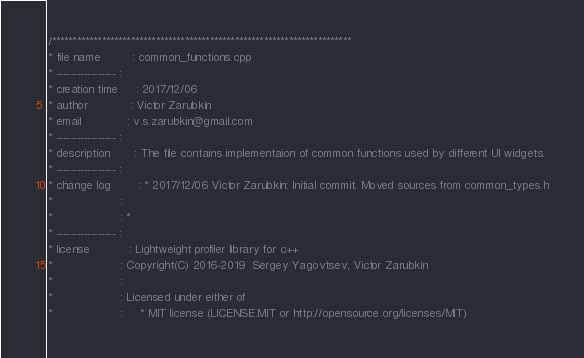Convert code to text. <code><loc_0><loc_0><loc_500><loc_500><_C++_>/************************************************************************
* file name         : common_functions.cpp
* ----------------- :
* creation time     : 2017/12/06
* author            : Victor Zarubkin
* email             : v.s.zarubkin@gmail.com
* ----------------- :
* description       : The file contains implementaion of common functions used by different UI widgets.
* ----------------- :
* change log        : * 2017/12/06 Victor Zarubkin: Initial commit. Moved sources from common_types.h
*                   :
*                   : *
* ----------------- :
* license           : Lightweight profiler library for c++
*                   : Copyright(C) 2016-2019  Sergey Yagovtsev, Victor Zarubkin
*                   :
*                   : Licensed under either of
*                   :     * MIT license (LICENSE.MIT or http://opensource.org/licenses/MIT)</code> 